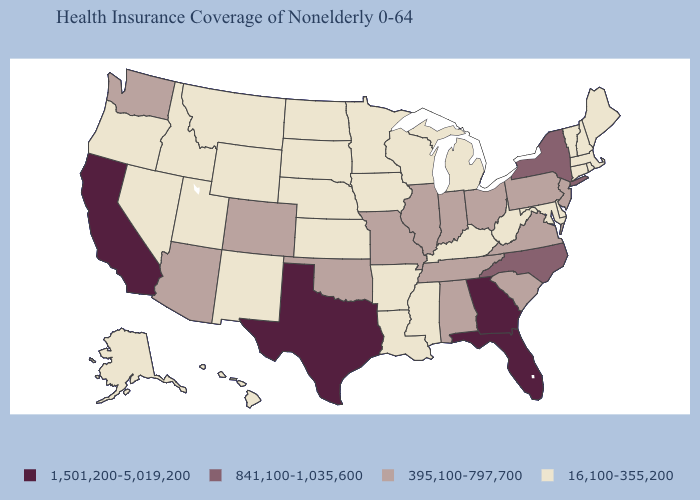Name the states that have a value in the range 841,100-1,035,600?
Quick response, please. New York, North Carolina. What is the lowest value in the South?
Keep it brief. 16,100-355,200. Which states have the lowest value in the USA?
Quick response, please. Alaska, Arkansas, Connecticut, Delaware, Hawaii, Idaho, Iowa, Kansas, Kentucky, Louisiana, Maine, Maryland, Massachusetts, Michigan, Minnesota, Mississippi, Montana, Nebraska, Nevada, New Hampshire, New Mexico, North Dakota, Oregon, Rhode Island, South Dakota, Utah, Vermont, West Virginia, Wisconsin, Wyoming. What is the value of Idaho?
Give a very brief answer. 16,100-355,200. What is the value of Ohio?
Keep it brief. 395,100-797,700. Name the states that have a value in the range 16,100-355,200?
Concise answer only. Alaska, Arkansas, Connecticut, Delaware, Hawaii, Idaho, Iowa, Kansas, Kentucky, Louisiana, Maine, Maryland, Massachusetts, Michigan, Minnesota, Mississippi, Montana, Nebraska, Nevada, New Hampshire, New Mexico, North Dakota, Oregon, Rhode Island, South Dakota, Utah, Vermont, West Virginia, Wisconsin, Wyoming. Name the states that have a value in the range 1,501,200-5,019,200?
Short answer required. California, Florida, Georgia, Texas. What is the value of Oregon?
Give a very brief answer. 16,100-355,200. Which states have the highest value in the USA?
Short answer required. California, Florida, Georgia, Texas. Name the states that have a value in the range 16,100-355,200?
Give a very brief answer. Alaska, Arkansas, Connecticut, Delaware, Hawaii, Idaho, Iowa, Kansas, Kentucky, Louisiana, Maine, Maryland, Massachusetts, Michigan, Minnesota, Mississippi, Montana, Nebraska, Nevada, New Hampshire, New Mexico, North Dakota, Oregon, Rhode Island, South Dakota, Utah, Vermont, West Virginia, Wisconsin, Wyoming. Name the states that have a value in the range 841,100-1,035,600?
Keep it brief. New York, North Carolina. What is the value of Washington?
Keep it brief. 395,100-797,700. Name the states that have a value in the range 841,100-1,035,600?
Concise answer only. New York, North Carolina. Name the states that have a value in the range 16,100-355,200?
Be succinct. Alaska, Arkansas, Connecticut, Delaware, Hawaii, Idaho, Iowa, Kansas, Kentucky, Louisiana, Maine, Maryland, Massachusetts, Michigan, Minnesota, Mississippi, Montana, Nebraska, Nevada, New Hampshire, New Mexico, North Dakota, Oregon, Rhode Island, South Dakota, Utah, Vermont, West Virginia, Wisconsin, Wyoming. What is the value of Iowa?
Answer briefly. 16,100-355,200. 